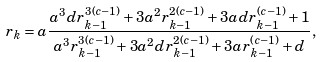<formula> <loc_0><loc_0><loc_500><loc_500>r _ { k } = a \frac { a ^ { 3 } d r _ { k - 1 } ^ { 3 ( c - 1 ) } + 3 a ^ { 2 } r _ { k - 1 } ^ { 2 ( c - 1 ) } + 3 a d r _ { k - 1 } ^ { ( c - 1 ) } + 1 } { a ^ { 3 } r _ { k - 1 } ^ { 3 ( c - 1 ) } + 3 a ^ { 2 } d r _ { k - 1 } ^ { 2 ( c - 1 ) } + 3 a r _ { k - 1 } ^ { ( c - 1 ) } + d } ,</formula> 